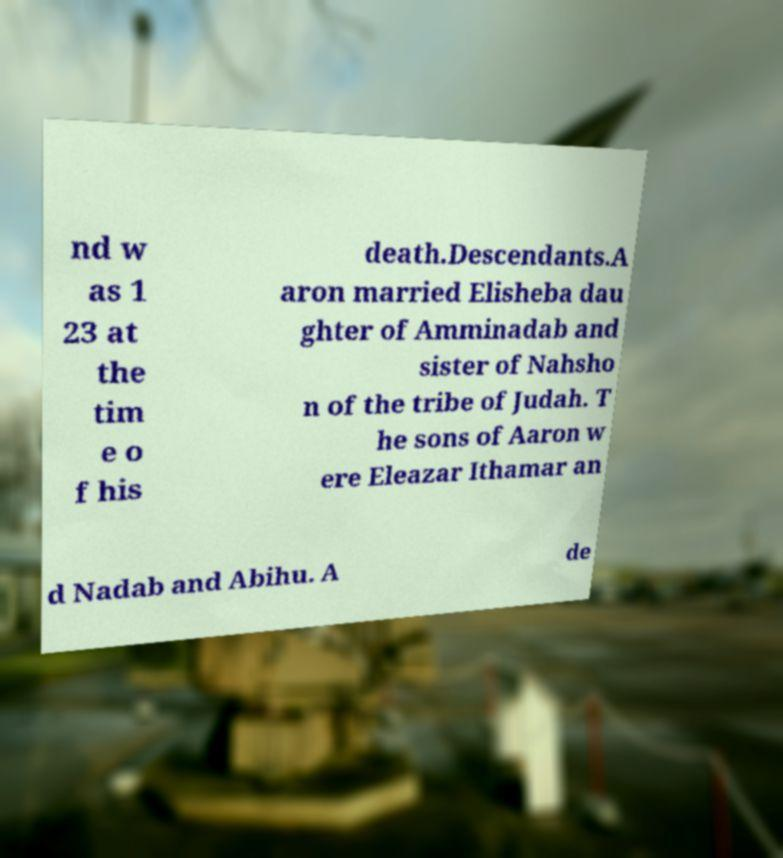There's text embedded in this image that I need extracted. Can you transcribe it verbatim? nd w as 1 23 at the tim e o f his death.Descendants.A aron married Elisheba dau ghter of Amminadab and sister of Nahsho n of the tribe of Judah. T he sons of Aaron w ere Eleazar Ithamar an d Nadab and Abihu. A de 